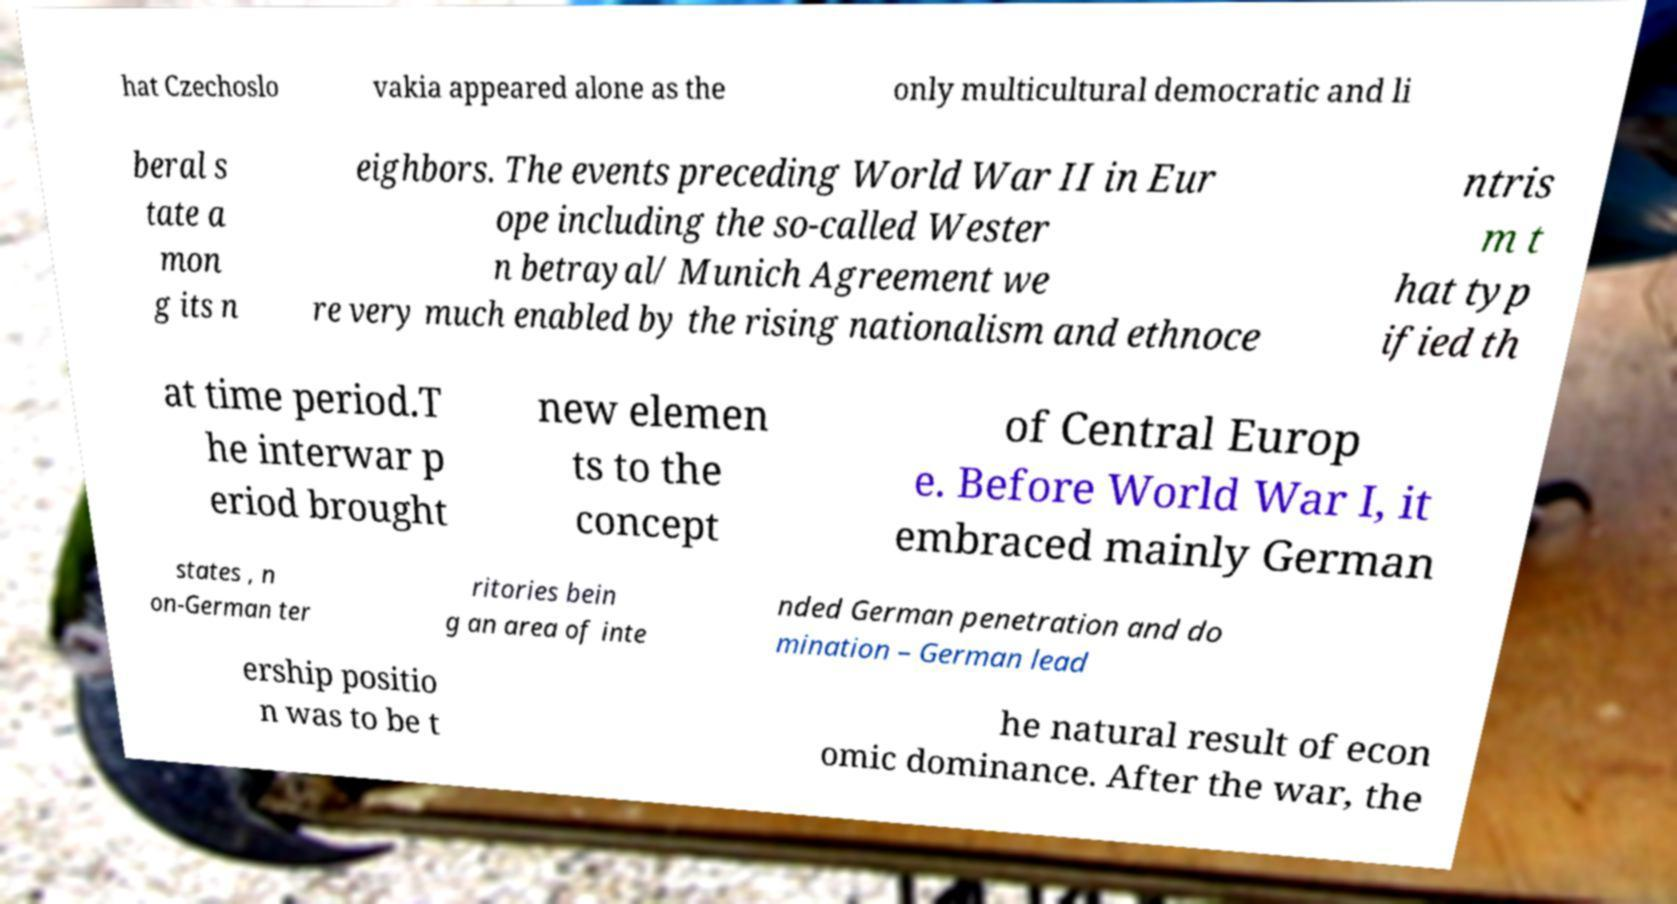There's text embedded in this image that I need extracted. Can you transcribe it verbatim? hat Czechoslo vakia appeared alone as the only multicultural democratic and li beral s tate a mon g its n eighbors. The events preceding World War II in Eur ope including the so-called Wester n betrayal/ Munich Agreement we re very much enabled by the rising nationalism and ethnoce ntris m t hat typ ified th at time period.T he interwar p eriod brought new elemen ts to the concept of Central Europ e. Before World War I, it embraced mainly German states , n on-German ter ritories bein g an area of inte nded German penetration and do mination – German lead ership positio n was to be t he natural result of econ omic dominance. After the war, the 